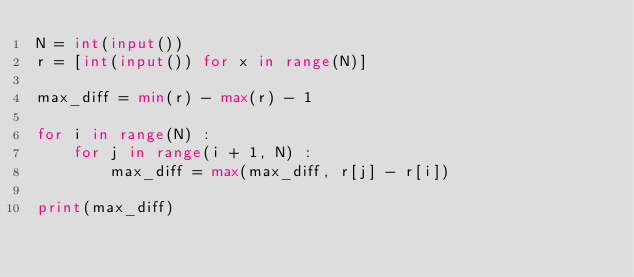<code> <loc_0><loc_0><loc_500><loc_500><_Python_>N = int(input())
r = [int(input()) for x in range(N)]

max_diff = min(r) - max(r) - 1

for i in range(N) :
    for j in range(i + 1, N) :
        max_diff = max(max_diff, r[j] - r[i])
        
print(max_diff)
</code> 